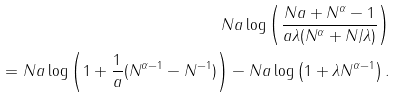Convert formula to latex. <formula><loc_0><loc_0><loc_500><loc_500>N a \log \left ( \frac { N a + N ^ { \alpha } - 1 } { a \lambda ( N ^ { \alpha } + { N } / { \lambda } ) } \right ) \\ = N a \log \left ( 1 + \frac { 1 } { a } ( N ^ { \alpha - 1 } - N ^ { - 1 } ) \right ) - N a \log \left ( 1 + \lambda N ^ { \alpha - 1 } \right ) .</formula> 